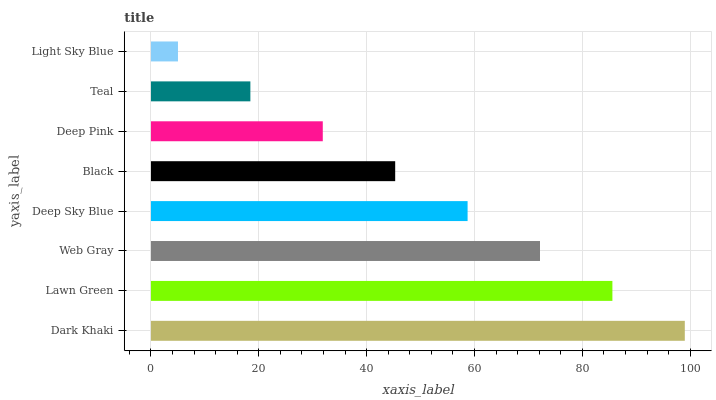Is Light Sky Blue the minimum?
Answer yes or no. Yes. Is Dark Khaki the maximum?
Answer yes or no. Yes. Is Lawn Green the minimum?
Answer yes or no. No. Is Lawn Green the maximum?
Answer yes or no. No. Is Dark Khaki greater than Lawn Green?
Answer yes or no. Yes. Is Lawn Green less than Dark Khaki?
Answer yes or no. Yes. Is Lawn Green greater than Dark Khaki?
Answer yes or no. No. Is Dark Khaki less than Lawn Green?
Answer yes or no. No. Is Deep Sky Blue the high median?
Answer yes or no. Yes. Is Black the low median?
Answer yes or no. Yes. Is Deep Pink the high median?
Answer yes or no. No. Is Dark Khaki the low median?
Answer yes or no. No. 